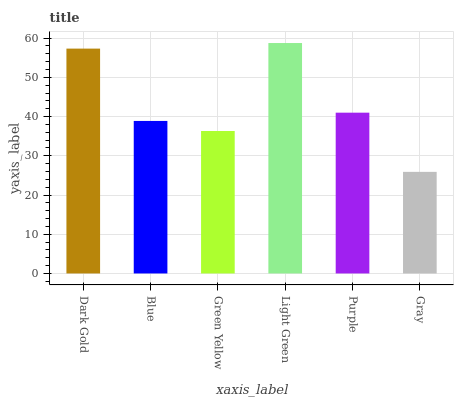Is Gray the minimum?
Answer yes or no. Yes. Is Light Green the maximum?
Answer yes or no. Yes. Is Blue the minimum?
Answer yes or no. No. Is Blue the maximum?
Answer yes or no. No. Is Dark Gold greater than Blue?
Answer yes or no. Yes. Is Blue less than Dark Gold?
Answer yes or no. Yes. Is Blue greater than Dark Gold?
Answer yes or no. No. Is Dark Gold less than Blue?
Answer yes or no. No. Is Purple the high median?
Answer yes or no. Yes. Is Blue the low median?
Answer yes or no. Yes. Is Light Green the high median?
Answer yes or no. No. Is Green Yellow the low median?
Answer yes or no. No. 